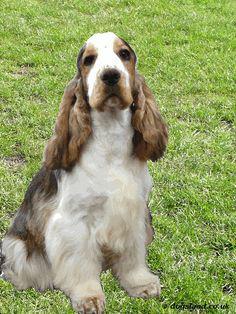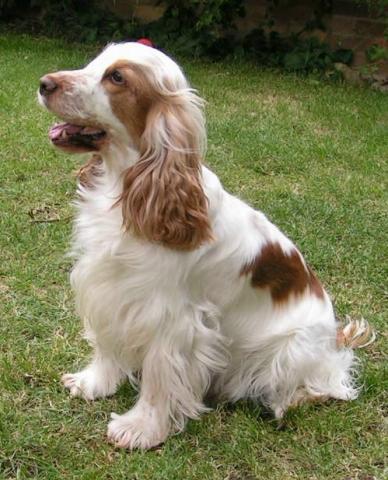The first image is the image on the left, the second image is the image on the right. Examine the images to the left and right. Is the description "The right photo shows a dog standing in the grass." accurate? Answer yes or no. No. The first image is the image on the left, the second image is the image on the right. Examine the images to the left and right. Is the description "There are two dogs shown in total" accurate? Answer yes or no. Yes. 